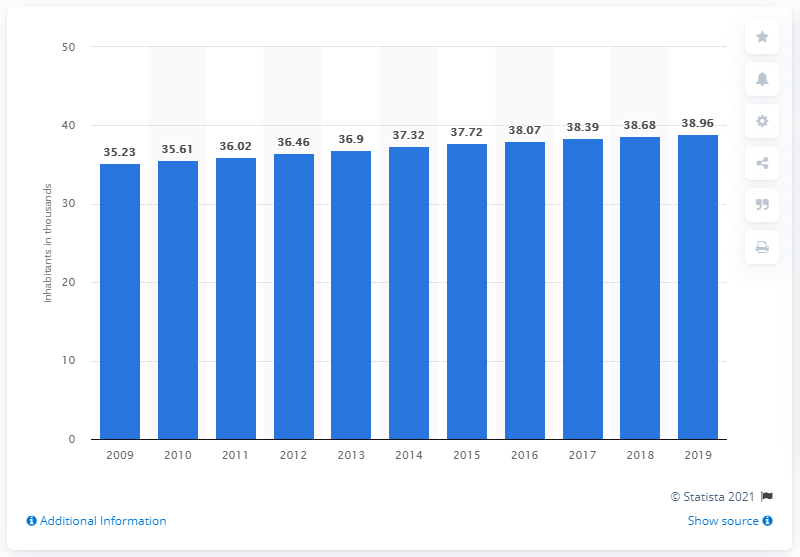Highlight a few significant elements in this photo. As of 2019, the population of Monaco was 38.96. 